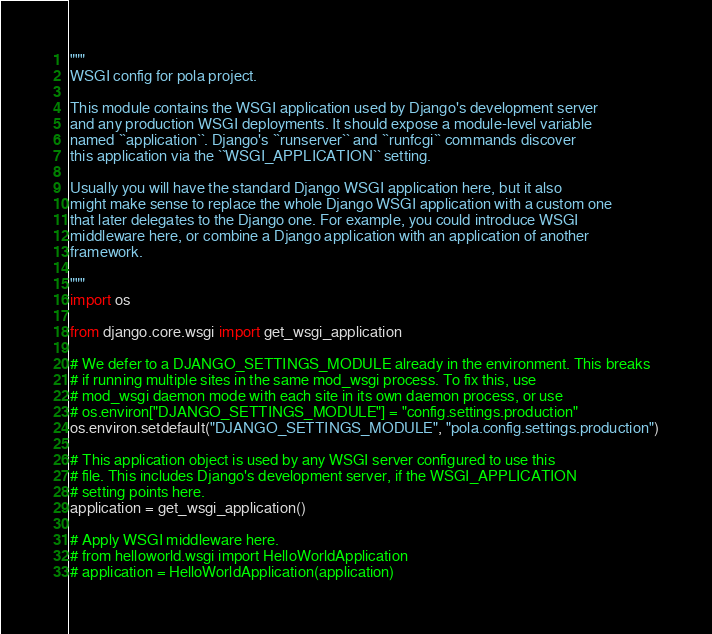Convert code to text. <code><loc_0><loc_0><loc_500><loc_500><_Python_>"""
WSGI config for pola project.

This module contains the WSGI application used by Django's development server
and any production WSGI deployments. It should expose a module-level variable
named ``application``. Django's ``runserver`` and ``runfcgi`` commands discover
this application via the ``WSGI_APPLICATION`` setting.

Usually you will have the standard Django WSGI application here, but it also
might make sense to replace the whole Django WSGI application with a custom one
that later delegates to the Django one. For example, you could introduce WSGI
middleware here, or combine a Django application with an application of another
framework.

"""
import os

from django.core.wsgi import get_wsgi_application

# We defer to a DJANGO_SETTINGS_MODULE already in the environment. This breaks
# if running multiple sites in the same mod_wsgi process. To fix this, use
# mod_wsgi daemon mode with each site in its own daemon process, or use
# os.environ["DJANGO_SETTINGS_MODULE"] = "config.settings.production"
os.environ.setdefault("DJANGO_SETTINGS_MODULE", "pola.config.settings.production")

# This application object is used by any WSGI server configured to use this
# file. This includes Django's development server, if the WSGI_APPLICATION
# setting points here.
application = get_wsgi_application()

# Apply WSGI middleware here.
# from helloworld.wsgi import HelloWorldApplication
# application = HelloWorldApplication(application)
</code> 